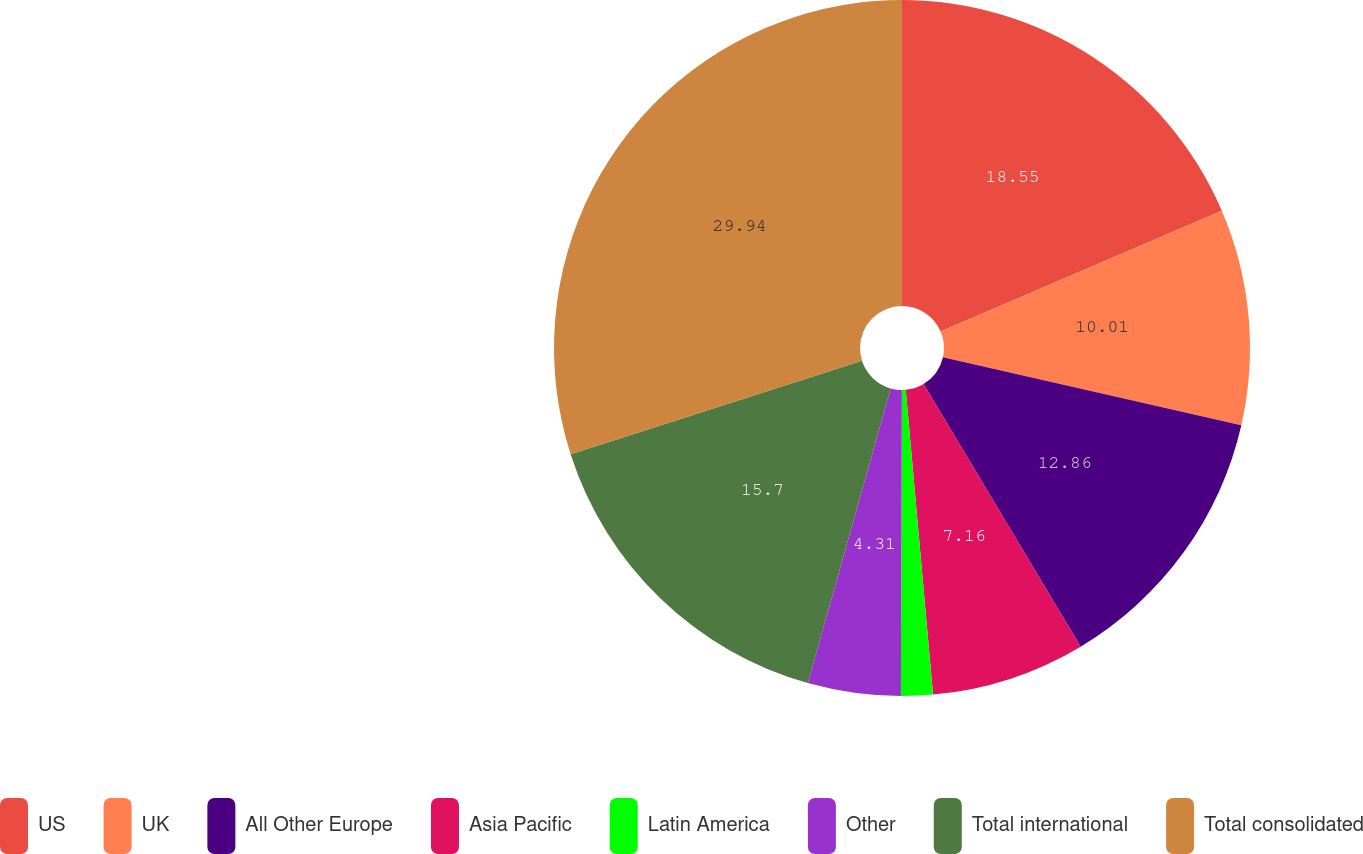Convert chart. <chart><loc_0><loc_0><loc_500><loc_500><pie_chart><fcel>US<fcel>UK<fcel>All Other Europe<fcel>Asia Pacific<fcel>Latin America<fcel>Other<fcel>Total international<fcel>Total consolidated<nl><fcel>18.55%<fcel>10.01%<fcel>12.86%<fcel>7.16%<fcel>1.47%<fcel>4.31%<fcel>15.7%<fcel>29.94%<nl></chart> 